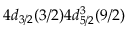<formula> <loc_0><loc_0><loc_500><loc_500>4 d _ { 3 / 2 } ( 3 / 2 ) 4 d _ { 5 / 2 } ^ { 3 } ( 9 / 2 )</formula> 